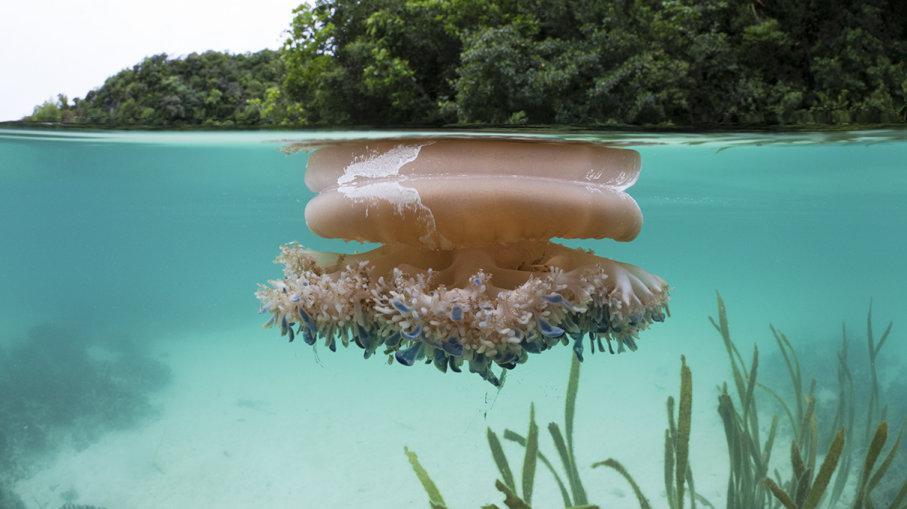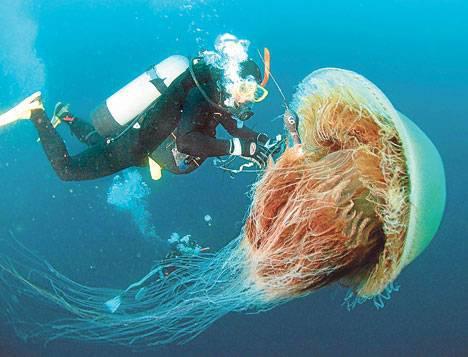The first image is the image on the left, the second image is the image on the right. Considering the images on both sides, is "At least one jellyfish has long, stringy tentacles." valid? Answer yes or no. Yes. The first image is the image on the left, the second image is the image on the right. Examine the images to the left and right. Is the description "The jellyfish on the right is yellowish, with a rounded top and a cauliflower-like bottom without long tendrils." accurate? Answer yes or no. No. 